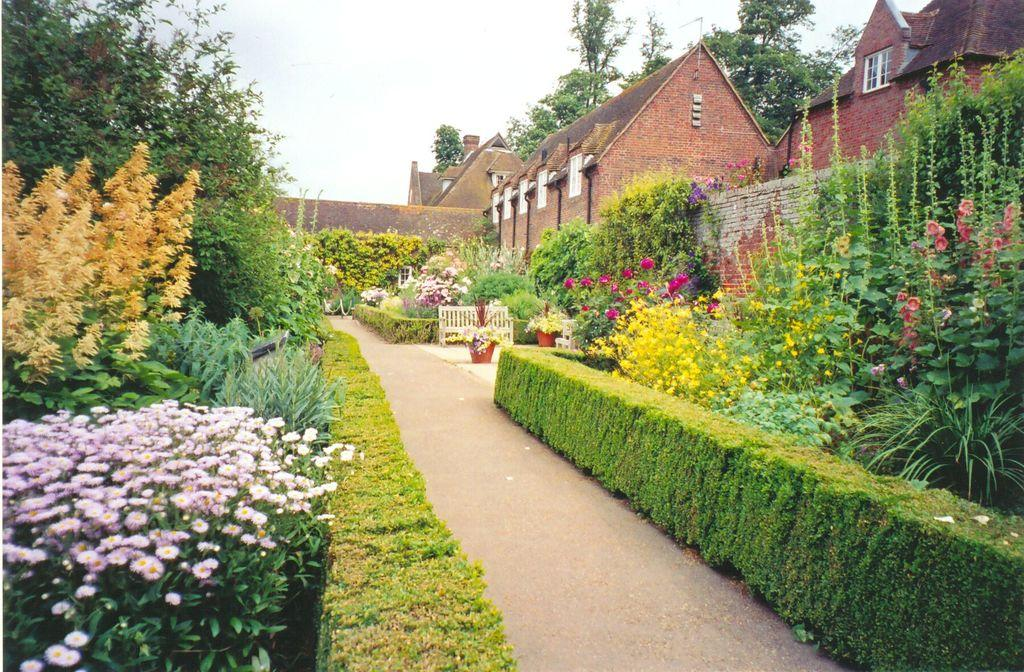What type of vegetation can be seen in the image? There are flowers, plants, house plants, and trees in the image. What type of structure is present in the image? There are buildings in the image. What can be seen in the background of the image? The sky is visible in the background of the image. What is the purpose of the fence in the image? The fence in the image may serve as a boundary or barrier. What is the path in the image used for? The path in the image may be used for walking or navigating through the area. What type of body is visible in the image? There is no body present in the image; it features flowers, plants, a path, a fence, and buildings. What type of power source can be seen in the image? There is no power source visible in the image; it primarily features vegetation and structures. 